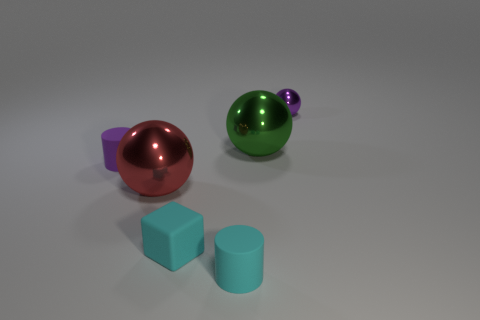There is a purple thing that is the same shape as the green metal object; what is it made of?
Make the answer very short. Metal. Is there a large red shiny object to the right of the large sphere left of the tiny cyan rubber object that is in front of the tiny cyan matte cube?
Offer a terse response. No. How many other objects are the same color as the small matte block?
Offer a terse response. 1. What number of metallic spheres are both on the left side of the green ball and behind the purple matte cylinder?
Make the answer very short. 0. What is the shape of the green metallic thing?
Provide a succinct answer. Sphere. What is the color of the rubber cylinder to the left of the large metallic thing in front of the big metallic object that is behind the purple matte thing?
Keep it short and to the point. Purple. There is a red sphere that is the same size as the green shiny sphere; what material is it?
Give a very brief answer. Metal. What number of things are either tiny cyan things behind the tiny cyan cylinder or big red cylinders?
Provide a short and direct response. 1. Are any tiny metal things visible?
Provide a short and direct response. Yes. There is a small purple object in front of the tiny purple metal thing; what is it made of?
Your answer should be very brief. Rubber. 